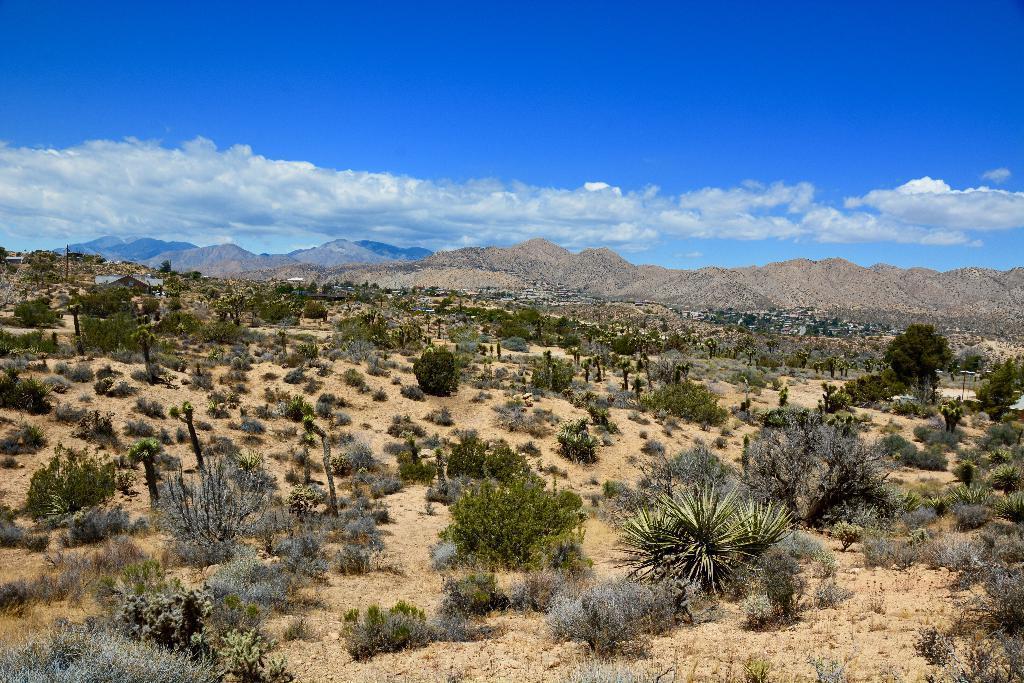Can you describe this image briefly? In this image we can see some trees/plants residing in the front region. And we can see sand. And some stony surface/mountain/hill is covered in the middle region. And the sky is blue with clouds. 